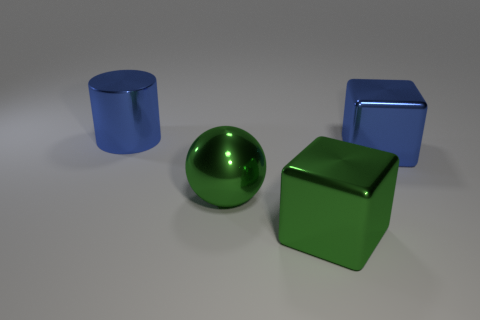Add 1 tiny brown matte things. How many objects exist? 5 Subtract all cyan balls. How many green blocks are left? 1 Subtract all big objects. Subtract all small blue cylinders. How many objects are left? 0 Add 3 green cubes. How many green cubes are left? 4 Add 2 blue cylinders. How many blue cylinders exist? 3 Subtract 0 gray cylinders. How many objects are left? 4 Subtract all spheres. How many objects are left? 3 Subtract 2 cubes. How many cubes are left? 0 Subtract all yellow cubes. Subtract all brown cylinders. How many cubes are left? 2 